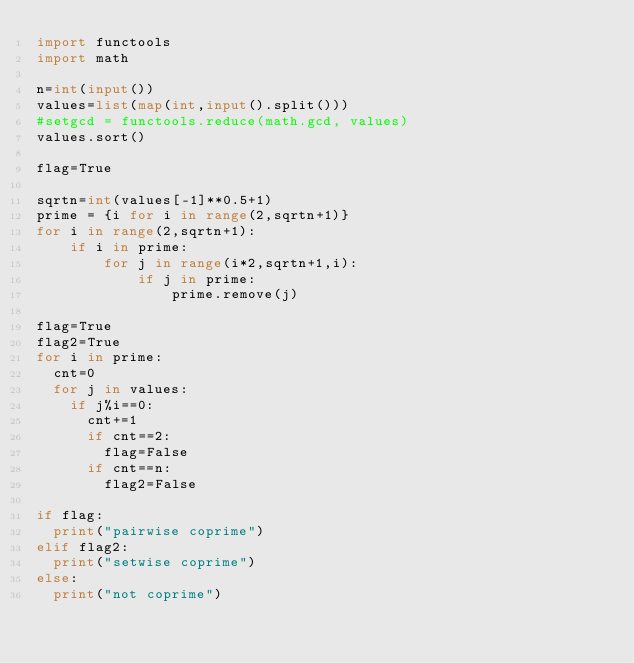Convert code to text. <code><loc_0><loc_0><loc_500><loc_500><_Python_>import functools
import math

n=int(input())
values=list(map(int,input().split()))
#setgcd = functools.reduce(math.gcd, values)
values.sort()

flag=True

sqrtn=int(values[-1]**0.5+1)
prime = {i for i in range(2,sqrtn+1)}
for i in range(2,sqrtn+1):
    if i in prime:
        for j in range(i*2,sqrtn+1,i):
            if j in prime:
                prime.remove(j)

flag=True
flag2=True
for i in prime:
  cnt=0
  for j in values:
    if j%i==0:
      cnt+=1
      if cnt==2:
        flag=False
      if cnt==n:
        flag2=False

if flag:
  print("pairwise coprime")
elif flag2:
  print("setwise coprime")
else:
  print("not coprime")</code> 